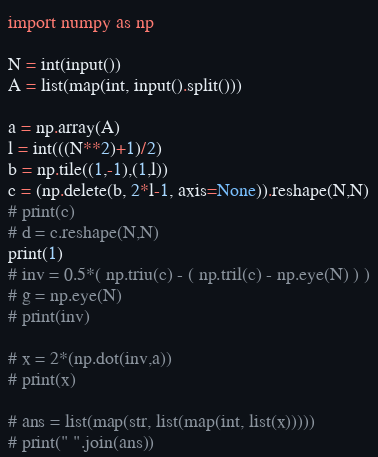<code> <loc_0><loc_0><loc_500><loc_500><_Python_>import numpy as np

N = int(input())
A = list(map(int, input().split()))

a = np.array(A)
l = int(((N**2)+1)/2)
b = np.tile((1,-1),(1,l))
c = (np.delete(b, 2*l-1, axis=None)).reshape(N,N)
# print(c)
# d = c.reshape(N,N)
print(1)
# inv = 0.5*( np.triu(c) - ( np.tril(c) - np.eye(N) ) )
# g = np.eye(N)
# print(inv)

# x = 2*(np.dot(inv,a))
# print(x)

# ans = list(map(str, list(map(int, list(x)))))
# print(" ".join(ans))</code> 